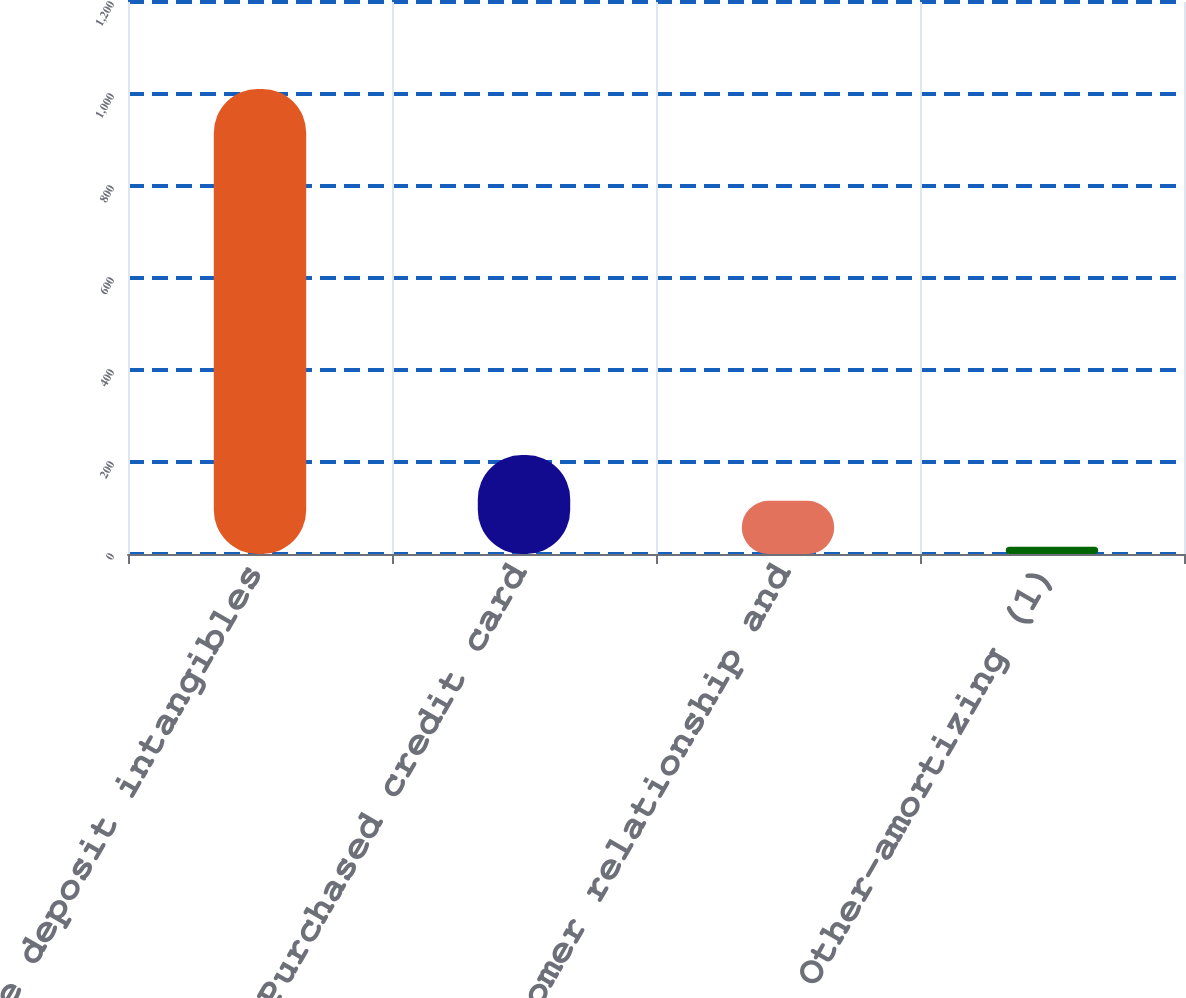<chart> <loc_0><loc_0><loc_500><loc_500><bar_chart><fcel>Core deposit intangibles<fcel>Purchased credit card<fcel>Customer relationship and<fcel>Other-amortizing (1)<nl><fcel>1011<fcel>215<fcel>115.5<fcel>16<nl></chart> 